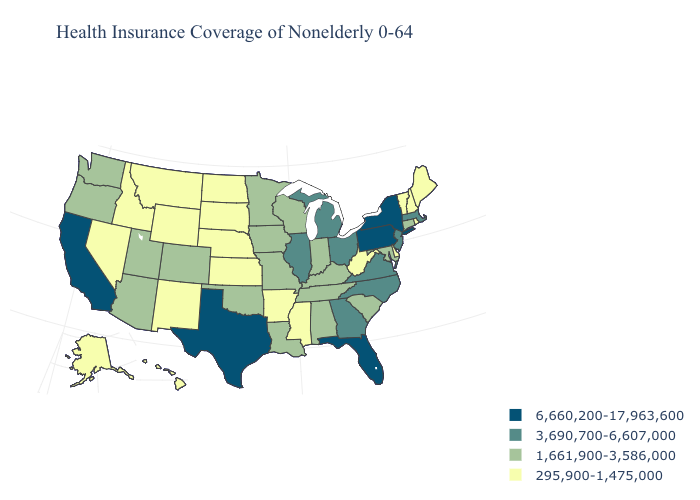What is the value of New Jersey?
Quick response, please. 3,690,700-6,607,000. What is the value of South Dakota?
Be succinct. 295,900-1,475,000. Among the states that border Michigan , does Indiana have the highest value?
Short answer required. No. Does Maine have the lowest value in the USA?
Write a very short answer. Yes. Among the states that border Pennsylvania , does New Jersey have the lowest value?
Be succinct. No. Name the states that have a value in the range 6,660,200-17,963,600?
Quick response, please. California, Florida, New York, Pennsylvania, Texas. Among the states that border Mississippi , does Alabama have the highest value?
Concise answer only. Yes. Is the legend a continuous bar?
Concise answer only. No. How many symbols are there in the legend?
Answer briefly. 4. What is the value of Montana?
Keep it brief. 295,900-1,475,000. Which states have the lowest value in the South?
Quick response, please. Arkansas, Delaware, Mississippi, West Virginia. Does Indiana have the same value as Oregon?
Concise answer only. Yes. Among the states that border West Virginia , which have the lowest value?
Give a very brief answer. Kentucky, Maryland. Which states have the lowest value in the Northeast?
Quick response, please. Maine, New Hampshire, Rhode Island, Vermont. What is the value of New Mexico?
Quick response, please. 295,900-1,475,000. 